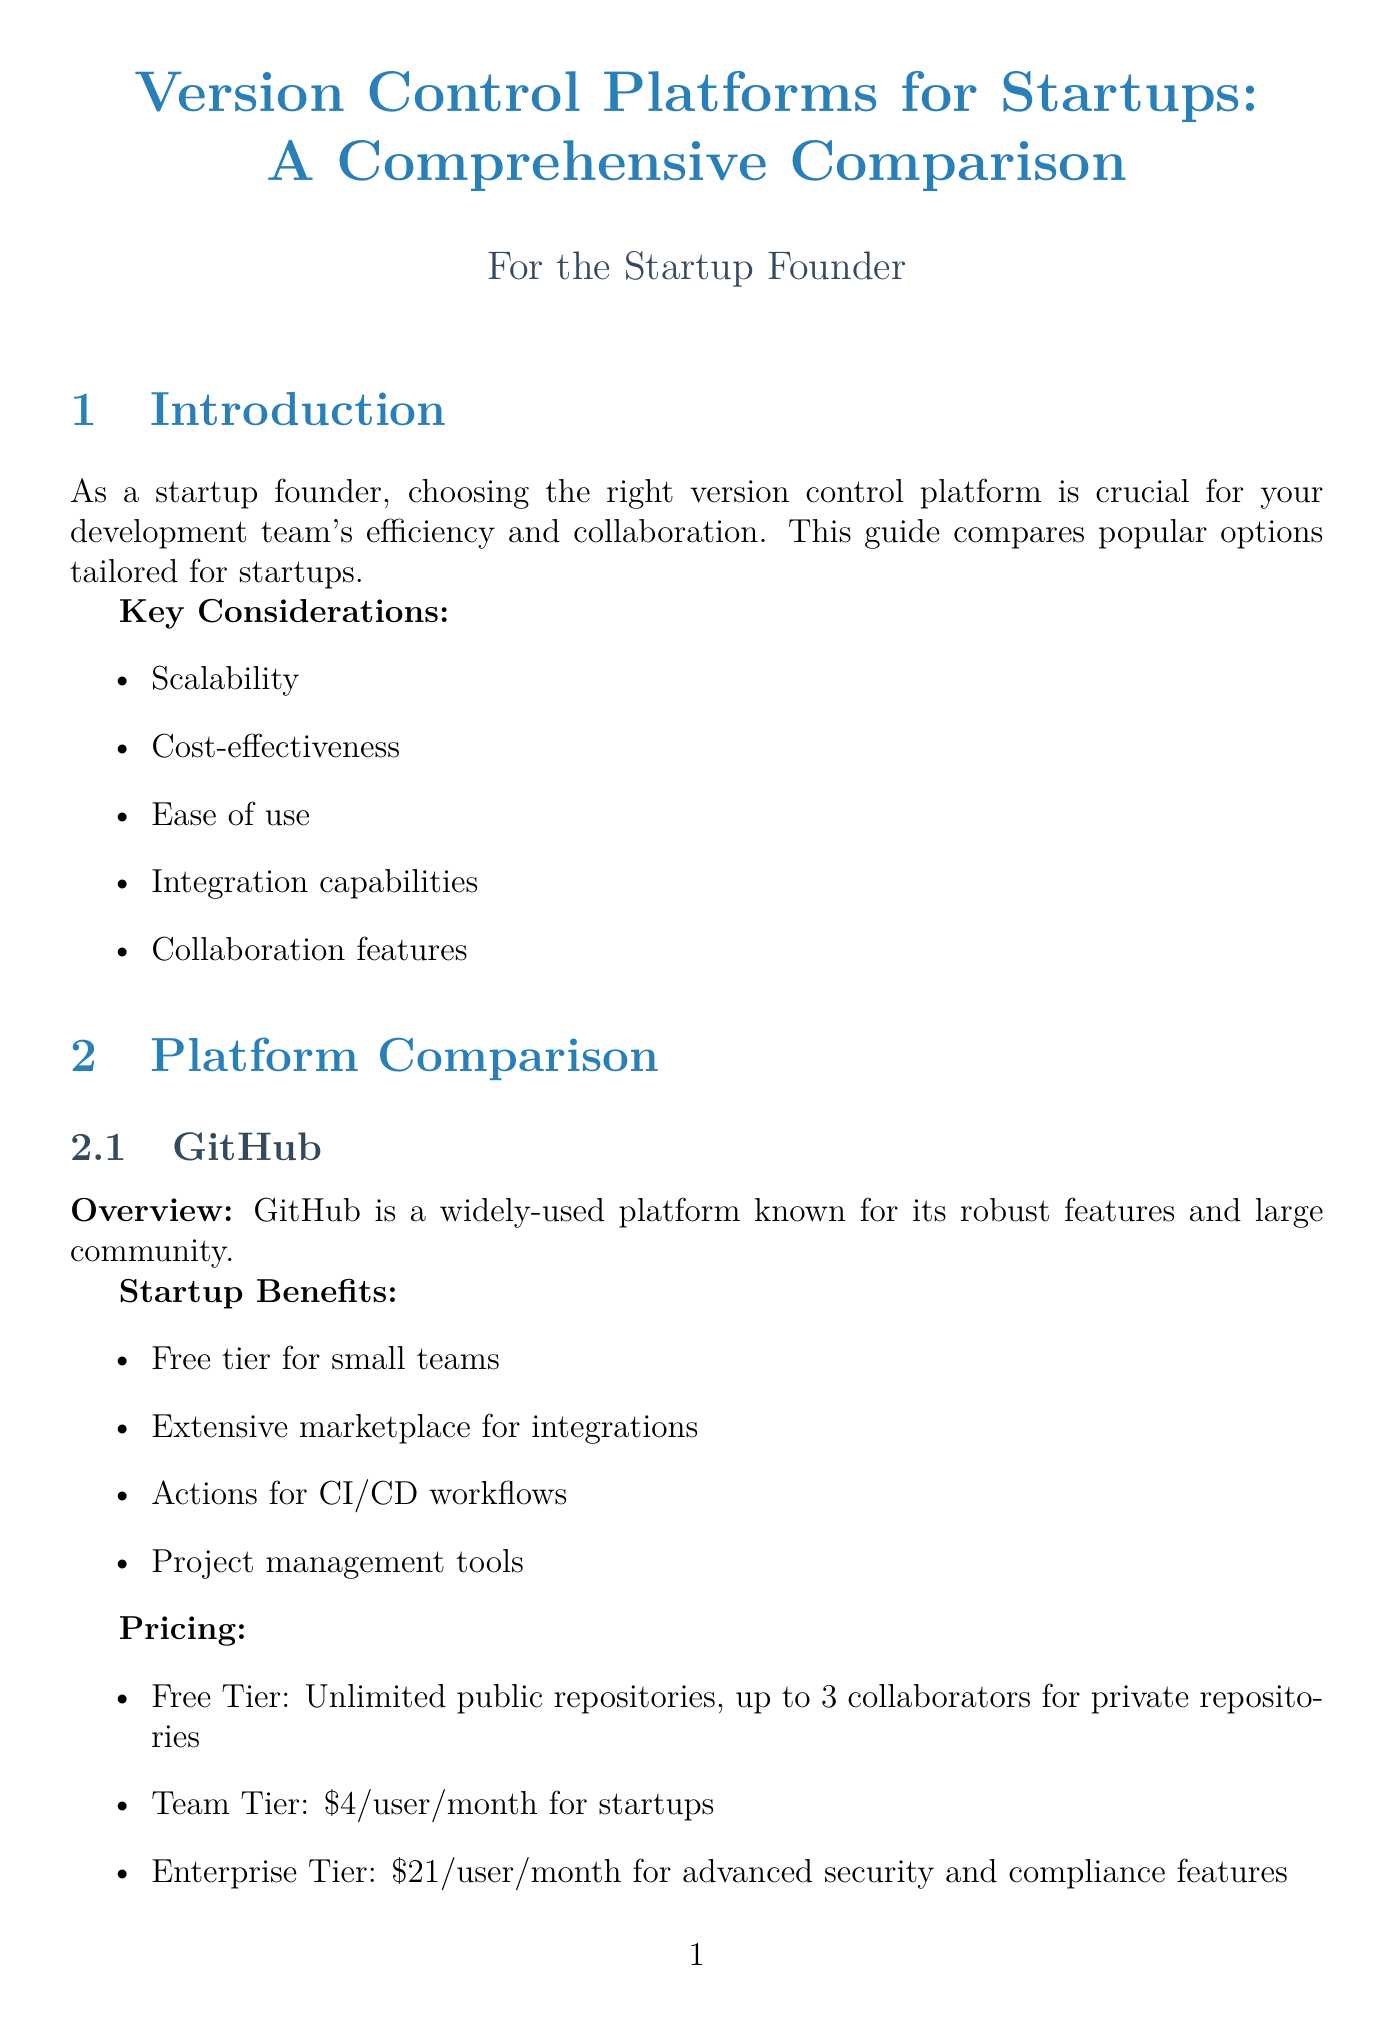What are the key considerations for choosing a version control platform? The key considerations for choosing a version control platform are scalability, cost-effectiveness, ease of use, integration capabilities, and collaboration features.
Answer: Scalability, cost-effectiveness, ease of use, integration capabilities, collaboration features What is the free tier pricing for GitHub? GitHub's free tier offers unlimited public repositories and up to 3 collaborators for private repositories.
Answer: Unlimited public repositories, up to 3 collaborators for private repositories What unique benefit does GitLab offer to startups? GitLab provides a self-hosted option for data control, which can be particularly beneficial to startups needing control over their data.
Answer: Self-hosted option for data control How much does the premium tier of Bitbucket cost? The premium tier of Bitbucket costs 6 dollars per user per month.
Answer: 6 dollars per user per month What is the total number of users allowed in Bitbucket's free tier? Bitbucket's free tier allows up to 5 users for unlimited private repositories.
Answer: Up to 5 users Which platform offers built-in CI/CD capabilities? GitLab is highlighted as offering built-in CI/CD capabilities as part of its complete DevOps platform.
Answer: GitLab What is the learning curve for using GitLab? The learning curve for using GitLab is described as steeper due to its all-in-one approach.
Answer: Steeper Which platform has a tight integration with Atlassian products? Bitbucket is part of the Atlassian suite, offering tight integration with other Atlassian products.
Answer: Bitbucket What should you assess to implement the right version control system? Assessing your startup's specific needs and growth projections is essential for implementing the right version control system.
Answer: Your startup's specific needs and growth projections 